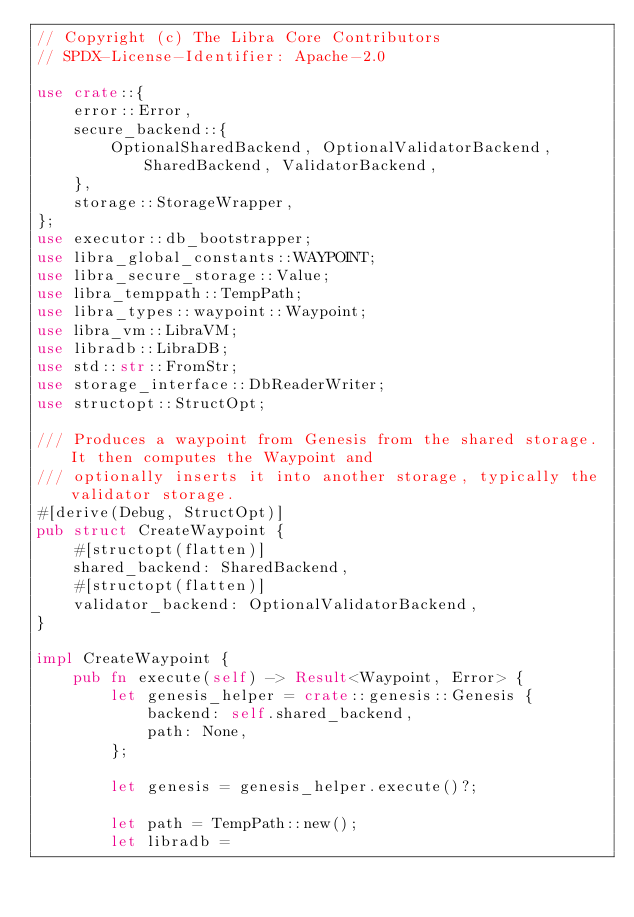<code> <loc_0><loc_0><loc_500><loc_500><_Rust_>// Copyright (c) The Libra Core Contributors
// SPDX-License-Identifier: Apache-2.0

use crate::{
    error::Error,
    secure_backend::{
        OptionalSharedBackend, OptionalValidatorBackend, SharedBackend, ValidatorBackend,
    },
    storage::StorageWrapper,
};
use executor::db_bootstrapper;
use libra_global_constants::WAYPOINT;
use libra_secure_storage::Value;
use libra_temppath::TempPath;
use libra_types::waypoint::Waypoint;
use libra_vm::LibraVM;
use libradb::LibraDB;
use std::str::FromStr;
use storage_interface::DbReaderWriter;
use structopt::StructOpt;

/// Produces a waypoint from Genesis from the shared storage. It then computes the Waypoint and
/// optionally inserts it into another storage, typically the validator storage.
#[derive(Debug, StructOpt)]
pub struct CreateWaypoint {
    #[structopt(flatten)]
    shared_backend: SharedBackend,
    #[structopt(flatten)]
    validator_backend: OptionalValidatorBackend,
}

impl CreateWaypoint {
    pub fn execute(self) -> Result<Waypoint, Error> {
        let genesis_helper = crate::genesis::Genesis {
            backend: self.shared_backend,
            path: None,
        };

        let genesis = genesis_helper.execute()?;

        let path = TempPath::new();
        let libradb =</code> 